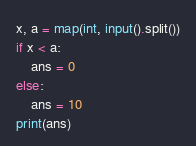Convert code to text. <code><loc_0><loc_0><loc_500><loc_500><_Python_>x, a = map(int, input().split())
if x < a:
    ans = 0
else:
    ans = 10
print(ans)</code> 